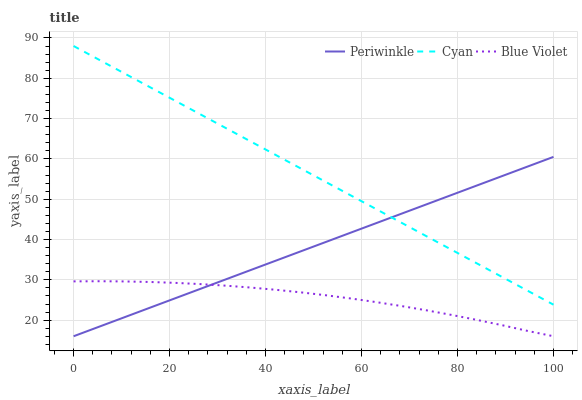Does Blue Violet have the minimum area under the curve?
Answer yes or no. Yes. Does Cyan have the maximum area under the curve?
Answer yes or no. Yes. Does Periwinkle have the minimum area under the curve?
Answer yes or no. No. Does Periwinkle have the maximum area under the curve?
Answer yes or no. No. Is Periwinkle the smoothest?
Answer yes or no. Yes. Is Blue Violet the roughest?
Answer yes or no. Yes. Is Blue Violet the smoothest?
Answer yes or no. No. Is Periwinkle the roughest?
Answer yes or no. No. Does Periwinkle have the lowest value?
Answer yes or no. Yes. Does Cyan have the highest value?
Answer yes or no. Yes. Does Periwinkle have the highest value?
Answer yes or no. No. Is Blue Violet less than Cyan?
Answer yes or no. Yes. Is Cyan greater than Blue Violet?
Answer yes or no. Yes. Does Periwinkle intersect Cyan?
Answer yes or no. Yes. Is Periwinkle less than Cyan?
Answer yes or no. No. Is Periwinkle greater than Cyan?
Answer yes or no. No. Does Blue Violet intersect Cyan?
Answer yes or no. No. 